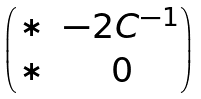Convert formula to latex. <formula><loc_0><loc_0><loc_500><loc_500>\begin{pmatrix} * & - 2 C ^ { - 1 } \\ * & 0 \end{pmatrix}</formula> 